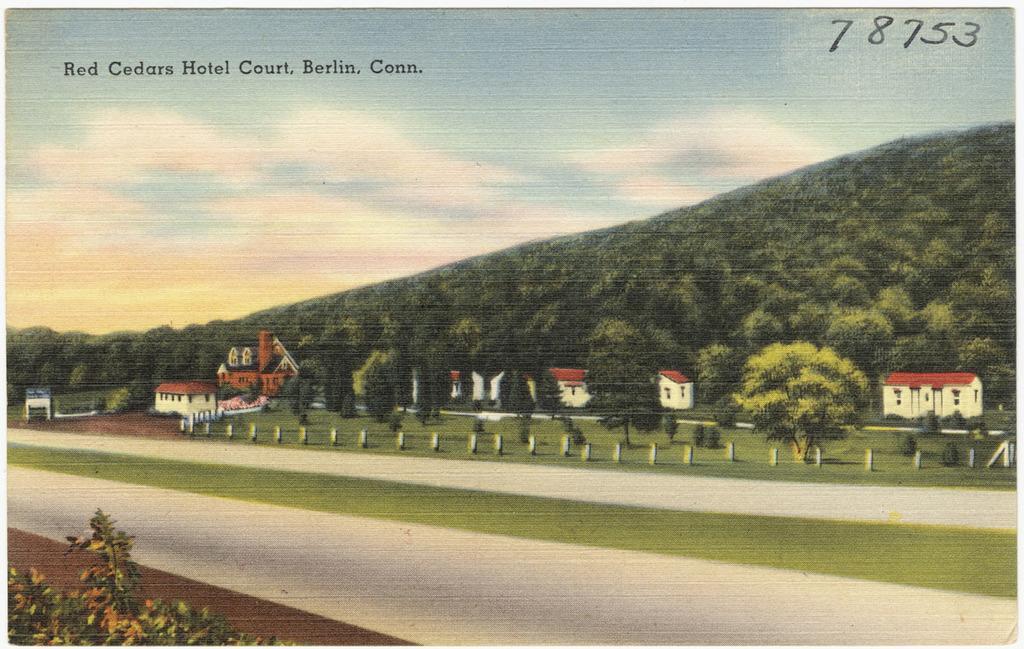How would you summarize this image in a sentence or two? In this image I can see it looks like a painting, in the middle there are trees and houses. At the top it is the sky and there is the text in black color. 